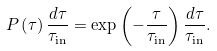Convert formula to latex. <formula><loc_0><loc_0><loc_500><loc_500>P \left ( \tau \right ) \frac { d \tau } { \tau _ { \text {in} } } = \exp \left ( - \frac { \tau } { \tau _ { \text {in} } } \right ) \frac { d \tau } { \tau _ { \text {in} } } .</formula> 